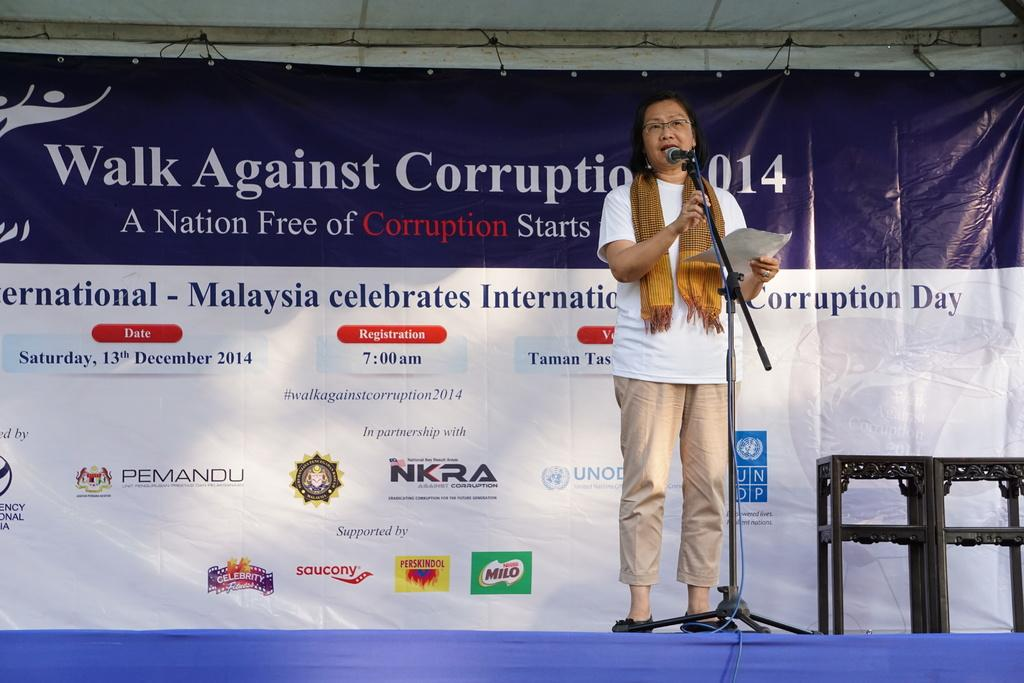What is the woman in the image doing? The woman is standing on a dais and holding a mic. What can be seen in the background of the image? There are tables and an advertisement in the background of the image. What type of reaction can be seen from the lamp in the image? There is no lamp present in the image, so it is not possible to determine any reaction. 